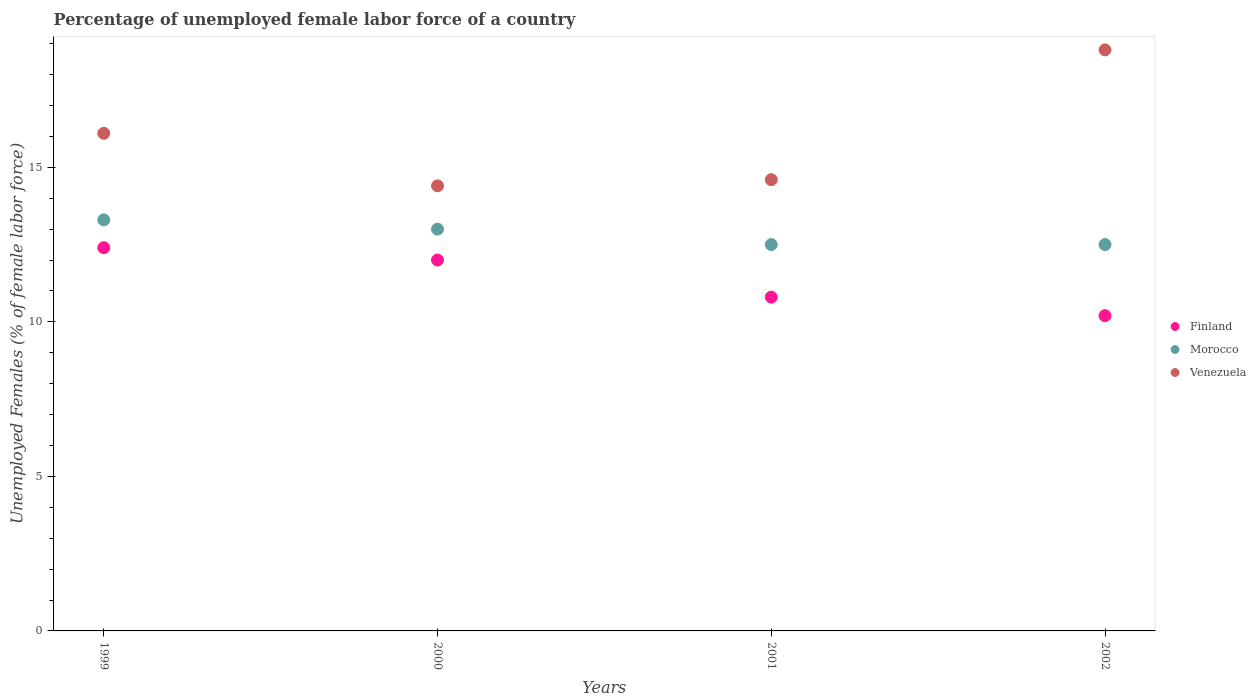How many different coloured dotlines are there?
Keep it short and to the point. 3. What is the percentage of unemployed female labor force in Morocco in 1999?
Make the answer very short. 13.3. Across all years, what is the maximum percentage of unemployed female labor force in Morocco?
Keep it short and to the point. 13.3. Across all years, what is the minimum percentage of unemployed female labor force in Finland?
Offer a very short reply. 10.2. In which year was the percentage of unemployed female labor force in Morocco maximum?
Keep it short and to the point. 1999. What is the total percentage of unemployed female labor force in Venezuela in the graph?
Your answer should be compact. 63.9. What is the difference between the percentage of unemployed female labor force in Finland in 1999 and that in 2000?
Keep it short and to the point. 0.4. What is the difference between the percentage of unemployed female labor force in Venezuela in 2002 and the percentage of unemployed female labor force in Finland in 2000?
Ensure brevity in your answer.  6.8. What is the average percentage of unemployed female labor force in Finland per year?
Your response must be concise. 11.35. In the year 2001, what is the difference between the percentage of unemployed female labor force in Morocco and percentage of unemployed female labor force in Finland?
Keep it short and to the point. 1.7. What is the ratio of the percentage of unemployed female labor force in Morocco in 1999 to that in 2000?
Offer a very short reply. 1.02. Is the difference between the percentage of unemployed female labor force in Morocco in 1999 and 2000 greater than the difference between the percentage of unemployed female labor force in Finland in 1999 and 2000?
Offer a terse response. No. What is the difference between the highest and the second highest percentage of unemployed female labor force in Venezuela?
Your answer should be compact. 2.7. What is the difference between the highest and the lowest percentage of unemployed female labor force in Finland?
Your answer should be compact. 2.2. Is the sum of the percentage of unemployed female labor force in Venezuela in 2000 and 2001 greater than the maximum percentage of unemployed female labor force in Morocco across all years?
Keep it short and to the point. Yes. Does the percentage of unemployed female labor force in Morocco monotonically increase over the years?
Your response must be concise. No. Is the percentage of unemployed female labor force in Morocco strictly less than the percentage of unemployed female labor force in Venezuela over the years?
Ensure brevity in your answer.  Yes. Does the graph contain grids?
Provide a succinct answer. No. What is the title of the graph?
Give a very brief answer. Percentage of unemployed female labor force of a country. Does "Serbia" appear as one of the legend labels in the graph?
Offer a terse response. No. What is the label or title of the X-axis?
Ensure brevity in your answer.  Years. What is the label or title of the Y-axis?
Ensure brevity in your answer.  Unemployed Females (% of female labor force). What is the Unemployed Females (% of female labor force) in Finland in 1999?
Make the answer very short. 12.4. What is the Unemployed Females (% of female labor force) of Morocco in 1999?
Ensure brevity in your answer.  13.3. What is the Unemployed Females (% of female labor force) in Venezuela in 1999?
Give a very brief answer. 16.1. What is the Unemployed Females (% of female labor force) of Finland in 2000?
Your answer should be very brief. 12. What is the Unemployed Females (% of female labor force) of Venezuela in 2000?
Give a very brief answer. 14.4. What is the Unemployed Females (% of female labor force) of Finland in 2001?
Provide a succinct answer. 10.8. What is the Unemployed Females (% of female labor force) of Venezuela in 2001?
Make the answer very short. 14.6. What is the Unemployed Females (% of female labor force) in Finland in 2002?
Provide a short and direct response. 10.2. What is the Unemployed Females (% of female labor force) of Morocco in 2002?
Your answer should be compact. 12.5. What is the Unemployed Females (% of female labor force) in Venezuela in 2002?
Give a very brief answer. 18.8. Across all years, what is the maximum Unemployed Females (% of female labor force) of Finland?
Keep it short and to the point. 12.4. Across all years, what is the maximum Unemployed Females (% of female labor force) in Morocco?
Ensure brevity in your answer.  13.3. Across all years, what is the maximum Unemployed Females (% of female labor force) in Venezuela?
Make the answer very short. 18.8. Across all years, what is the minimum Unemployed Females (% of female labor force) in Finland?
Offer a terse response. 10.2. Across all years, what is the minimum Unemployed Females (% of female labor force) in Morocco?
Offer a terse response. 12.5. Across all years, what is the minimum Unemployed Females (% of female labor force) of Venezuela?
Provide a succinct answer. 14.4. What is the total Unemployed Females (% of female labor force) in Finland in the graph?
Your answer should be compact. 45.4. What is the total Unemployed Females (% of female labor force) of Morocco in the graph?
Your response must be concise. 51.3. What is the total Unemployed Females (% of female labor force) in Venezuela in the graph?
Your response must be concise. 63.9. What is the difference between the Unemployed Females (% of female labor force) in Morocco in 1999 and that in 2000?
Provide a short and direct response. 0.3. What is the difference between the Unemployed Females (% of female labor force) of Venezuela in 1999 and that in 2000?
Make the answer very short. 1.7. What is the difference between the Unemployed Females (% of female labor force) in Finland in 1999 and that in 2001?
Keep it short and to the point. 1.6. What is the difference between the Unemployed Females (% of female labor force) in Morocco in 1999 and that in 2002?
Your answer should be very brief. 0.8. What is the difference between the Unemployed Females (% of female labor force) of Finland in 1999 and the Unemployed Females (% of female labor force) of Venezuela in 2000?
Offer a very short reply. -2. What is the difference between the Unemployed Females (% of female labor force) in Morocco in 1999 and the Unemployed Females (% of female labor force) in Venezuela in 2000?
Provide a short and direct response. -1.1. What is the difference between the Unemployed Females (% of female labor force) of Finland in 1999 and the Unemployed Females (% of female labor force) of Morocco in 2001?
Your answer should be compact. -0.1. What is the difference between the Unemployed Females (% of female labor force) in Finland in 1999 and the Unemployed Females (% of female labor force) in Venezuela in 2001?
Provide a succinct answer. -2.2. What is the difference between the Unemployed Females (% of female labor force) of Finland in 1999 and the Unemployed Females (% of female labor force) of Venezuela in 2002?
Offer a very short reply. -6.4. What is the difference between the Unemployed Females (% of female labor force) in Morocco in 1999 and the Unemployed Females (% of female labor force) in Venezuela in 2002?
Make the answer very short. -5.5. What is the difference between the Unemployed Females (% of female labor force) in Finland in 2000 and the Unemployed Females (% of female labor force) in Morocco in 2001?
Ensure brevity in your answer.  -0.5. What is the difference between the Unemployed Females (% of female labor force) in Finland in 2000 and the Unemployed Females (% of female labor force) in Venezuela in 2001?
Offer a terse response. -2.6. What is the difference between the Unemployed Females (% of female labor force) of Morocco in 2000 and the Unemployed Females (% of female labor force) of Venezuela in 2001?
Provide a succinct answer. -1.6. What is the difference between the Unemployed Females (% of female labor force) in Finland in 2000 and the Unemployed Females (% of female labor force) in Morocco in 2002?
Make the answer very short. -0.5. What is the difference between the Unemployed Females (% of female labor force) in Finland in 2000 and the Unemployed Females (% of female labor force) in Venezuela in 2002?
Your answer should be compact. -6.8. What is the difference between the Unemployed Females (% of female labor force) of Morocco in 2000 and the Unemployed Females (% of female labor force) of Venezuela in 2002?
Provide a short and direct response. -5.8. What is the difference between the Unemployed Females (% of female labor force) in Finland in 2001 and the Unemployed Females (% of female labor force) in Morocco in 2002?
Provide a succinct answer. -1.7. What is the average Unemployed Females (% of female labor force) in Finland per year?
Provide a succinct answer. 11.35. What is the average Unemployed Females (% of female labor force) in Morocco per year?
Make the answer very short. 12.82. What is the average Unemployed Females (% of female labor force) of Venezuela per year?
Offer a terse response. 15.97. In the year 1999, what is the difference between the Unemployed Females (% of female labor force) of Finland and Unemployed Females (% of female labor force) of Venezuela?
Your response must be concise. -3.7. In the year 1999, what is the difference between the Unemployed Females (% of female labor force) in Morocco and Unemployed Females (% of female labor force) in Venezuela?
Offer a very short reply. -2.8. In the year 2000, what is the difference between the Unemployed Females (% of female labor force) of Finland and Unemployed Females (% of female labor force) of Morocco?
Give a very brief answer. -1. In the year 2000, what is the difference between the Unemployed Females (% of female labor force) of Morocco and Unemployed Females (% of female labor force) of Venezuela?
Ensure brevity in your answer.  -1.4. In the year 2001, what is the difference between the Unemployed Females (% of female labor force) of Finland and Unemployed Females (% of female labor force) of Venezuela?
Ensure brevity in your answer.  -3.8. In the year 2001, what is the difference between the Unemployed Females (% of female labor force) in Morocco and Unemployed Females (% of female labor force) in Venezuela?
Your answer should be compact. -2.1. In the year 2002, what is the difference between the Unemployed Females (% of female labor force) in Finland and Unemployed Females (% of female labor force) in Morocco?
Provide a succinct answer. -2.3. In the year 2002, what is the difference between the Unemployed Females (% of female labor force) of Morocco and Unemployed Females (% of female labor force) of Venezuela?
Your response must be concise. -6.3. What is the ratio of the Unemployed Females (% of female labor force) in Morocco in 1999 to that in 2000?
Your response must be concise. 1.02. What is the ratio of the Unemployed Females (% of female labor force) in Venezuela in 1999 to that in 2000?
Make the answer very short. 1.12. What is the ratio of the Unemployed Females (% of female labor force) in Finland in 1999 to that in 2001?
Make the answer very short. 1.15. What is the ratio of the Unemployed Females (% of female labor force) of Morocco in 1999 to that in 2001?
Make the answer very short. 1.06. What is the ratio of the Unemployed Females (% of female labor force) of Venezuela in 1999 to that in 2001?
Provide a short and direct response. 1.1. What is the ratio of the Unemployed Females (% of female labor force) in Finland in 1999 to that in 2002?
Ensure brevity in your answer.  1.22. What is the ratio of the Unemployed Females (% of female labor force) in Morocco in 1999 to that in 2002?
Offer a terse response. 1.06. What is the ratio of the Unemployed Females (% of female labor force) of Venezuela in 1999 to that in 2002?
Make the answer very short. 0.86. What is the ratio of the Unemployed Females (% of female labor force) of Venezuela in 2000 to that in 2001?
Your response must be concise. 0.99. What is the ratio of the Unemployed Females (% of female labor force) in Finland in 2000 to that in 2002?
Offer a terse response. 1.18. What is the ratio of the Unemployed Females (% of female labor force) in Morocco in 2000 to that in 2002?
Provide a succinct answer. 1.04. What is the ratio of the Unemployed Females (% of female labor force) of Venezuela in 2000 to that in 2002?
Give a very brief answer. 0.77. What is the ratio of the Unemployed Females (% of female labor force) in Finland in 2001 to that in 2002?
Keep it short and to the point. 1.06. What is the ratio of the Unemployed Females (% of female labor force) in Venezuela in 2001 to that in 2002?
Make the answer very short. 0.78. 